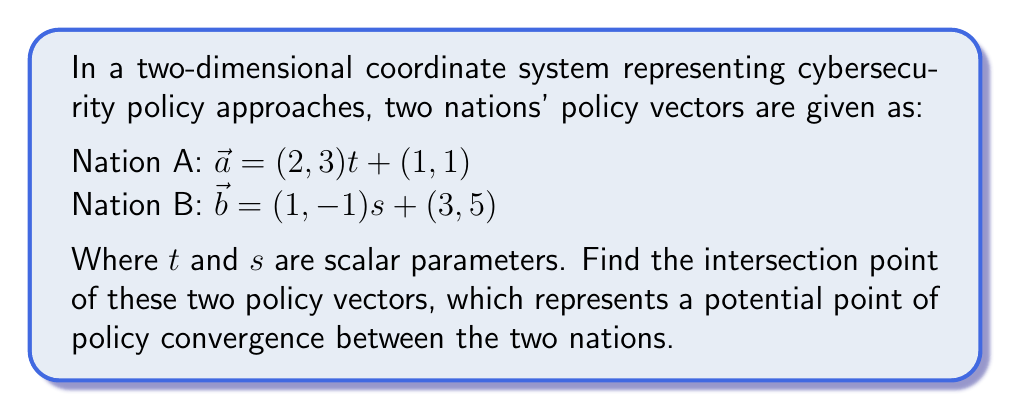Can you solve this math problem? To find the intersection point of these two vectors, we need to set their components equal to each other and solve for the parameters $t$ and $s$.

1) Set the x-components equal:
   $2t + 1 = s + 3$

2) Set the y-components equal:
   $3t + 1 = -s + 5$

3) From equation 1, express $s$ in terms of $t$:
   $s = 2t - 2$

4) Substitute this into equation 2:
   $3t + 1 = -(2t - 2) + 5$
   $3t + 1 = -2t + 7$
   $5t = 6$
   $t = \frac{6}{5} = 1.2$

5) Substitute $t$ back into the equation for $s$:
   $s = 2(1.2) - 2 = 0.4$

6) Now that we have $t$ and $s$, we can find the intersection point by plugging $t$ into Nation A's vector equation:

   $\vec{a} = (2, 3)(1.2) + (1, 1)$
   $\vec{a} = (2.4, 3.6) + (1, 1)$
   $\vec{a} = (3.4, 4.6)$

7) We can verify this by plugging $s$ into Nation B's vector equation:

   $\vec{b} = (1, -1)(0.4) + (3, 5)$
   $\vec{b} = (0.4, -0.4) + (3, 5)$
   $\vec{b} = (3.4, 4.6)$

Both equations yield the same point, confirming our solution.
Answer: The intersection point of the two cybersecurity policy vectors is $(3.4, 4.6)$. 